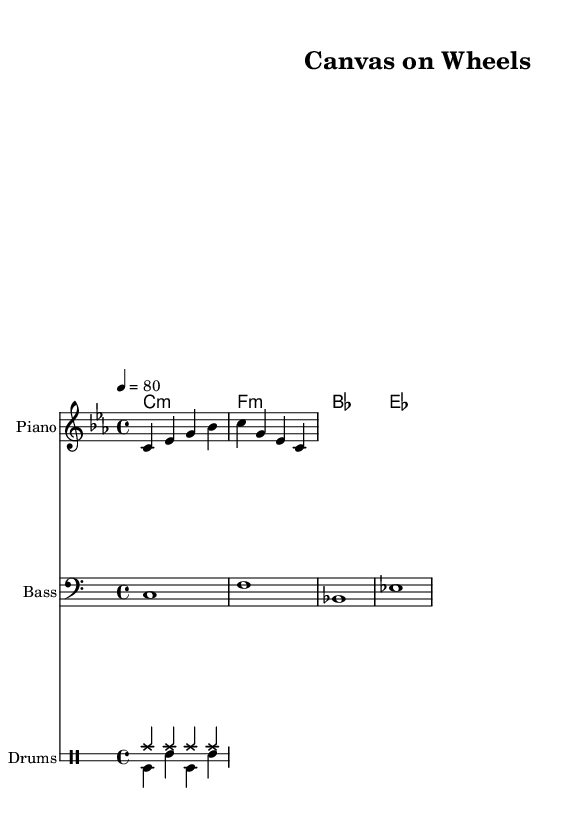What is the key signature of this music? The key signature is C minor, which has three flats (B flat, E flat, and A flat). This can be identified by the placement of the flat symbols at the beginning of the staff.
Answer: C minor What is the time signature of this music? The time signature is 4/4, indicated by the numbers displayed at the beginning of the staff. This means there are four beats in each measure and the quarter note gets one beat.
Answer: 4/4 What is the tempo marking of this piece? The tempo marking indicates that the piece should be played at a speed of 80 beats per minute, as noted above the staff with "4 = 80".
Answer: 80 How many measures are in the melody? The melody consists of two measures, as indicated by the bar lines dividing the music, with four beats in each measure under the 4/4 time signature.
Answer: 2 What chord is played in the first measure? The chord in the first measure is C minor, as denoted by "c:m" in the chord names section. This signifies the chord's name and its quality.
Answer: C minor Which instrument has the highest pitch in this score? The piano part has the highest pitch, as it is written an octave higher than the bass and features notes from the treble clef, distinguishing it from the lower tones of the bass and drums.
Answer: Piano How many different drum patterns are present in this score? There are two different drum patterns illustrated: one for the hi-hat (hh) and one for the bass drum and snare (bd and sn). These are shown in the drummode section which divides the different rhythms played by the percussion instruments.
Answer: 2 